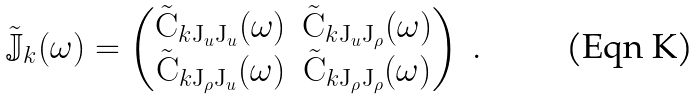Convert formula to latex. <formula><loc_0><loc_0><loc_500><loc_500>\tilde { \mathbb { J } } _ { k } ( \omega ) = \left ( \begin{matrix} \tilde { \mathrm C } _ { k { \mathrm J } _ { u } { \mathrm J } _ { u } } ( \omega ) & \tilde { \mathrm C } _ { k { \mathrm J } _ { u } { \mathrm J } _ { \rho } } ( \omega ) \\ \tilde { \mathrm C } _ { k { \mathrm J } _ { \rho } { \mathrm J } _ { u } } ( \omega ) & \tilde { \mathrm C } _ { k { \mathrm J } _ { \rho } { \mathrm J } _ { \rho } } ( \omega ) \\ \end{matrix} \right ) \ .</formula> 